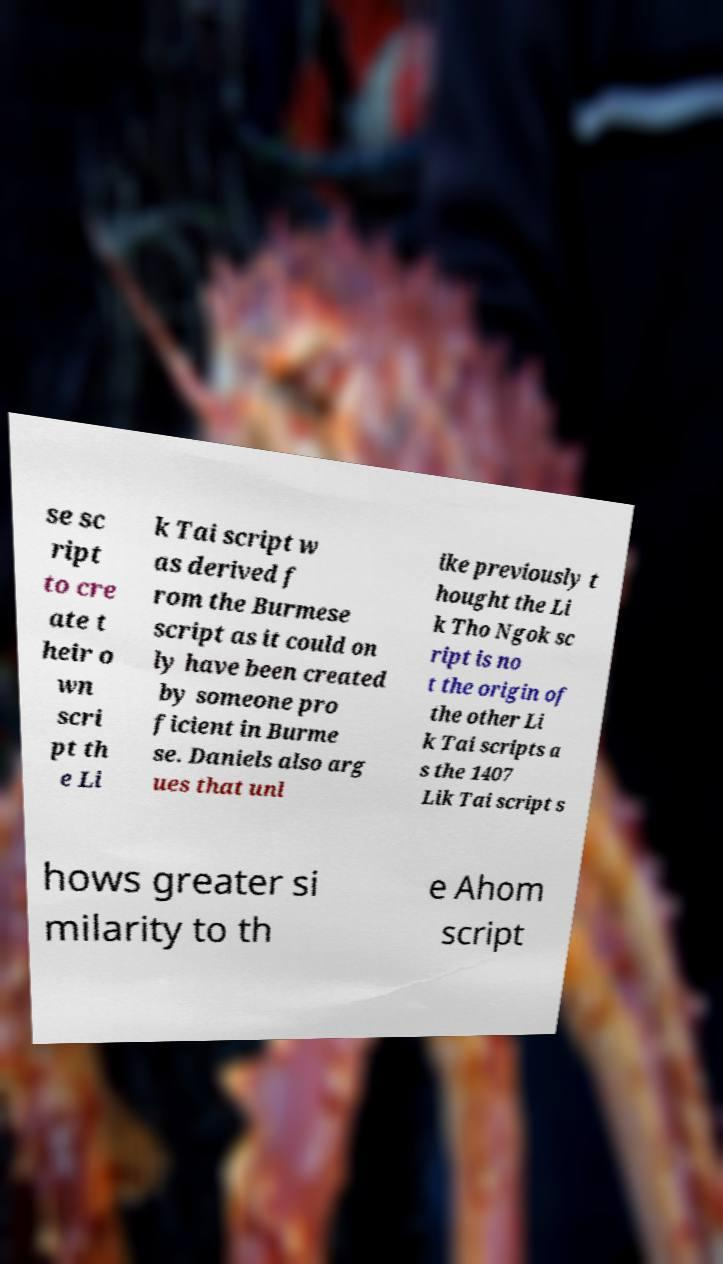Can you read and provide the text displayed in the image?This photo seems to have some interesting text. Can you extract and type it out for me? se sc ript to cre ate t heir o wn scri pt th e Li k Tai script w as derived f rom the Burmese script as it could on ly have been created by someone pro ficient in Burme se. Daniels also arg ues that unl ike previously t hought the Li k Tho Ngok sc ript is no t the origin of the other Li k Tai scripts a s the 1407 Lik Tai script s hows greater si milarity to th e Ahom script 